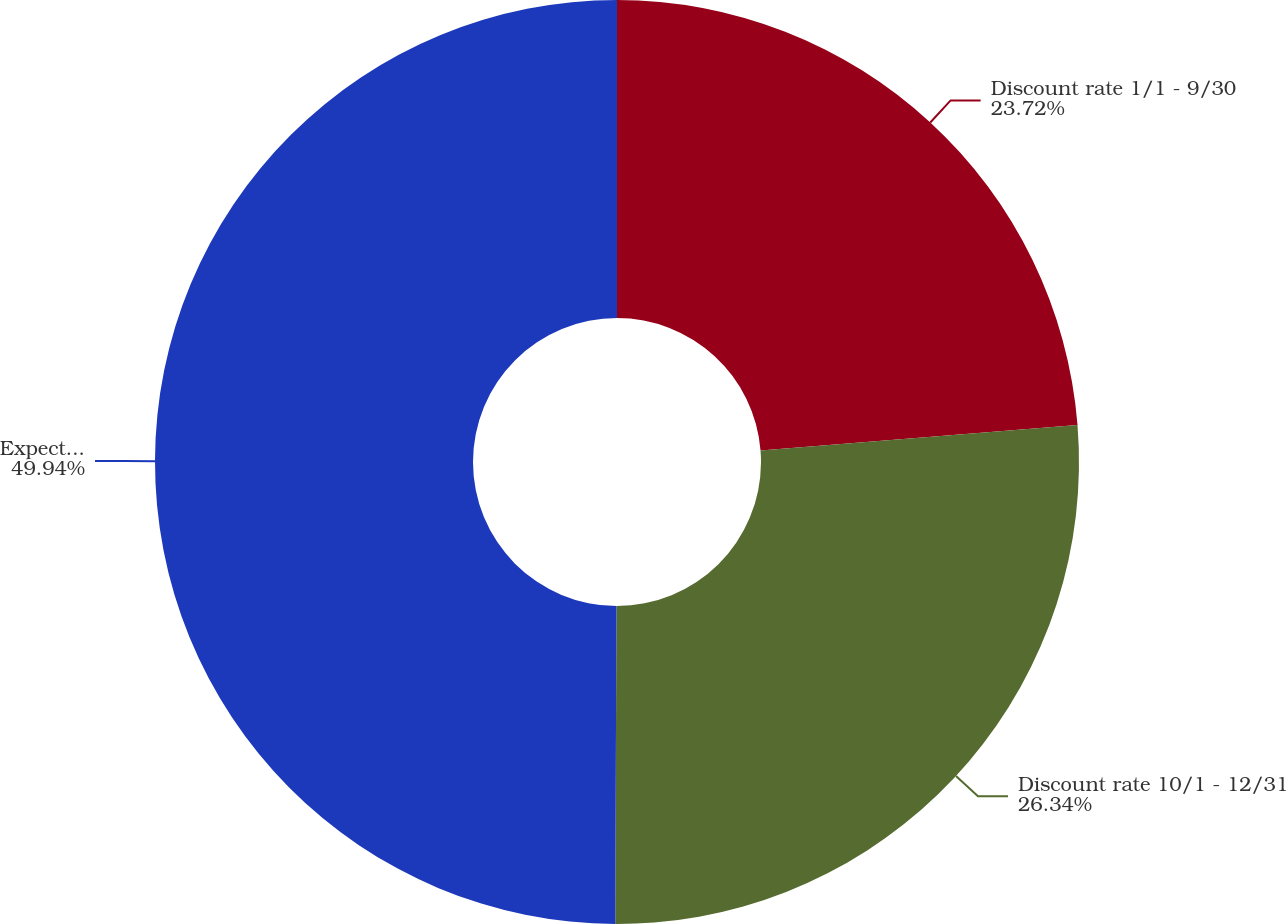Convert chart to OTSL. <chart><loc_0><loc_0><loc_500><loc_500><pie_chart><fcel>Discount rate 1/1 - 9/30<fcel>Discount rate 10/1 - 12/31<fcel>Expected return on plan assets<nl><fcel>23.72%<fcel>26.34%<fcel>49.94%<nl></chart> 